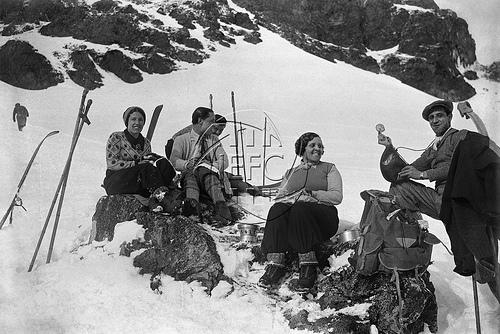What is one of the people sitting on in the image? One of the people is sitting on a rock. What can be observed about the rocks in the image?  The rocks have cracks in them and are sticking out of the snow. What are some people in the image doing in the snow? Some people in the image are sitting on rocks and others are climbing the hill. Name the type of shoe a woman is wearing in the image and describe their design. The woman is wearing snow boots with a black and white design. In the image, describe the appearance of the woman's sweater. The woman's sweater has a diamond pattern. What items related to skiing can be found in the image? Skis stuck in the snow are present in the image. What type of headwear is a man in the image wearing?   A man in the image is wearing a flat cap. Identify the footwear of the woman in the image. The woman is wearing rugged snow boots. What type of pants is a woman wearing in the image?  The woman is wearing black slacks. Describe the scene on the mountainside. It's a snowy scene with a group of people sitting in the snow, surrounded by rocks, and skis stuck in the snow. 